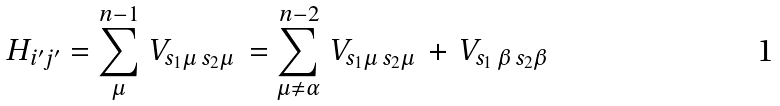Convert formula to latex. <formula><loc_0><loc_0><loc_500><loc_500>H _ { i ^ { \prime } j ^ { \prime } } = \sum _ { \mu } ^ { n - 1 } \, V _ { s _ { 1 } \mu \, s _ { 2 } \mu } \, = \sum _ { \mu \neq \alpha } ^ { n - 2 } \, V _ { s _ { 1 } \mu \, s _ { 2 } \mu } \, + \, V _ { s _ { 1 } \, \beta \, s _ { 2 } \beta }</formula> 